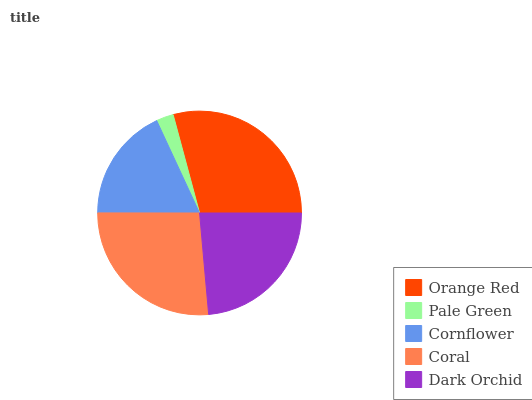Is Pale Green the minimum?
Answer yes or no. Yes. Is Orange Red the maximum?
Answer yes or no. Yes. Is Cornflower the minimum?
Answer yes or no. No. Is Cornflower the maximum?
Answer yes or no. No. Is Cornflower greater than Pale Green?
Answer yes or no. Yes. Is Pale Green less than Cornflower?
Answer yes or no. Yes. Is Pale Green greater than Cornflower?
Answer yes or no. No. Is Cornflower less than Pale Green?
Answer yes or no. No. Is Dark Orchid the high median?
Answer yes or no. Yes. Is Dark Orchid the low median?
Answer yes or no. Yes. Is Cornflower the high median?
Answer yes or no. No. Is Orange Red the low median?
Answer yes or no. No. 